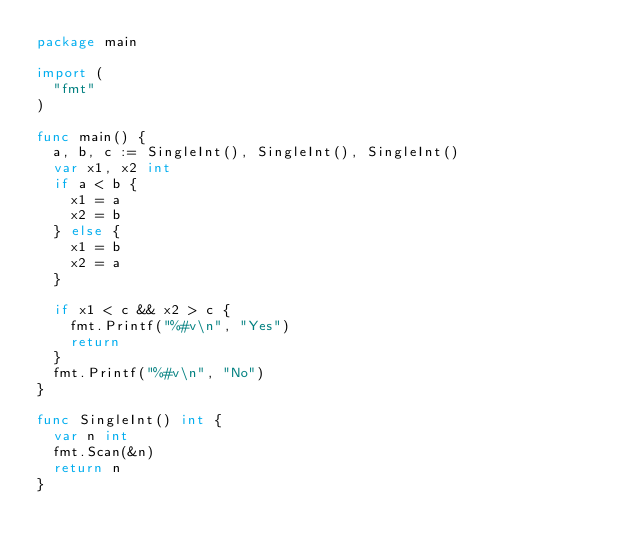<code> <loc_0><loc_0><loc_500><loc_500><_Go_>package main

import (
	"fmt"
)

func main() {
	a, b, c := SingleInt(), SingleInt(), SingleInt()
	var x1, x2 int
	if a < b {
		x1 = a
		x2 = b
	} else {
		x1 = b
		x2 = a
	}

	if x1 < c && x2 > c {
		fmt.Printf("%#v\n", "Yes")
		return
	}
	fmt.Printf("%#v\n", "No")
}

func SingleInt() int {
	var n int
	fmt.Scan(&n)
	return n
}
</code> 